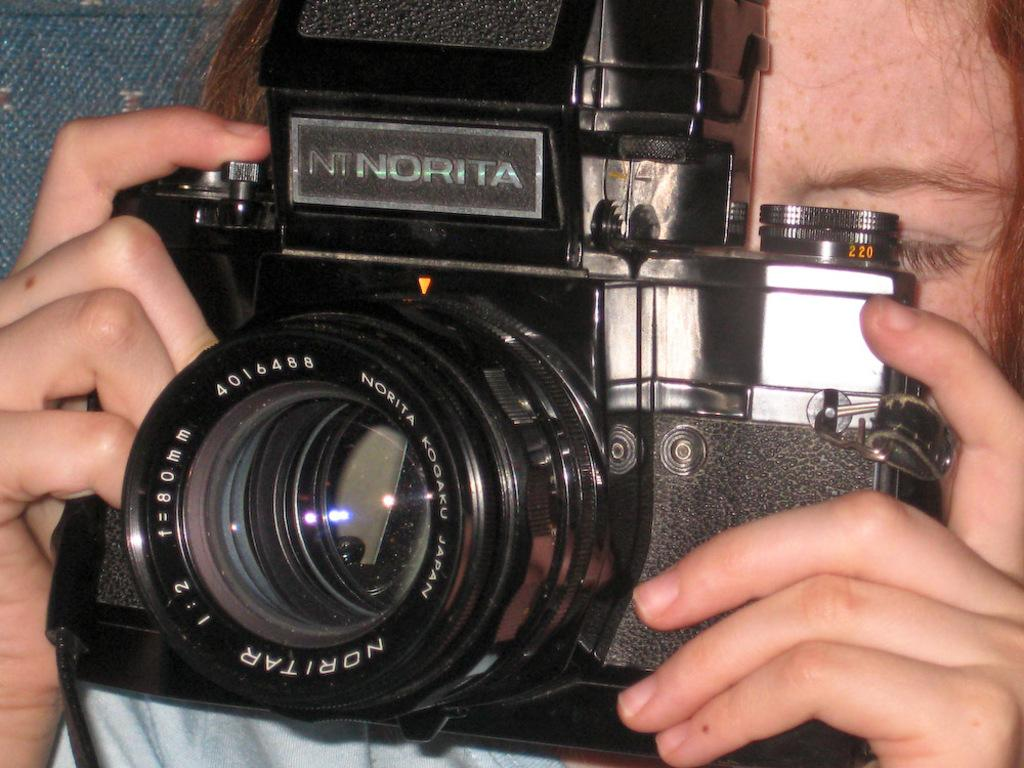What is the main subject of the image? There is a person in the image. What is the person holding in the image? The person is holding a camera. What type of brass instrument is the person playing in the image? There is no brass instrument present in the image; the person is holding a camera. 